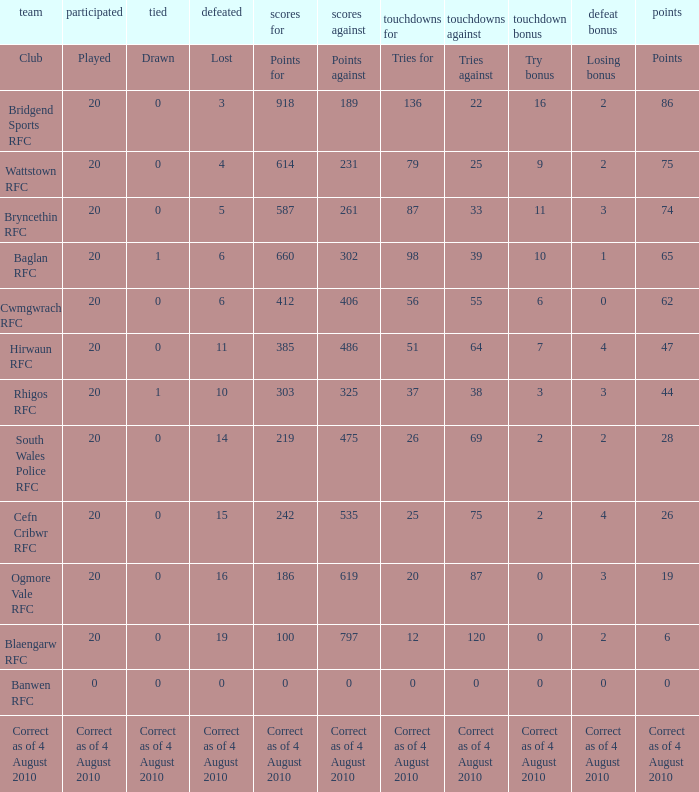What is absent when the points against amount to 231? 4.0. 